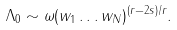<formula> <loc_0><loc_0><loc_500><loc_500>\Lambda _ { 0 } \sim \omega ( w _ { 1 } \dots w _ { N } ) ^ { ( r - 2 s ) / r } .</formula> 